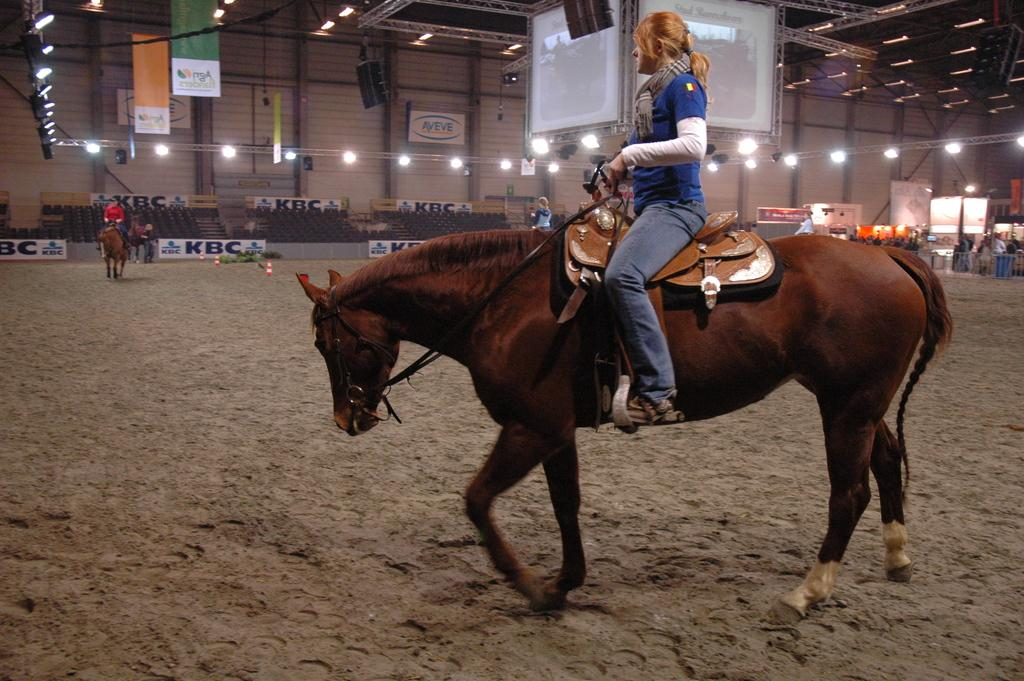What is the person in the image doing? The person is sitting on a horse in the image. What type of surface is visible on the ground? There is sand on the ground in the image. What can be seen in the background of the image? There is a wall in the background of the image. What type of seating is present in the image? There are seats in the image. What type of decorations are present in the image? Banners are present in the image. What type of lighting is visible in the image? Lights are visible in the image. What type of display devices are present in the image? Screens are present in the image. How many horses are visible in the image? There are horses in the image. What type of pie is being served on the horse in the image? There is no pie present in the image; the person is sitting on a horse. 